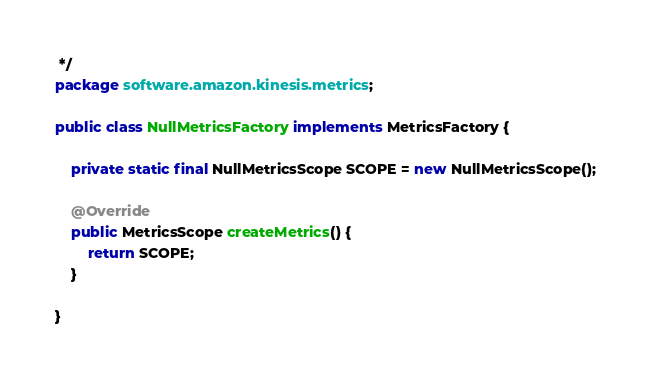Convert code to text. <code><loc_0><loc_0><loc_500><loc_500><_Java_> */
package software.amazon.kinesis.metrics;

public class NullMetricsFactory implements MetricsFactory {

    private static final NullMetricsScope SCOPE = new NullMetricsScope();

    @Override
    public MetricsScope createMetrics() {
        return SCOPE;
    }

}
</code> 